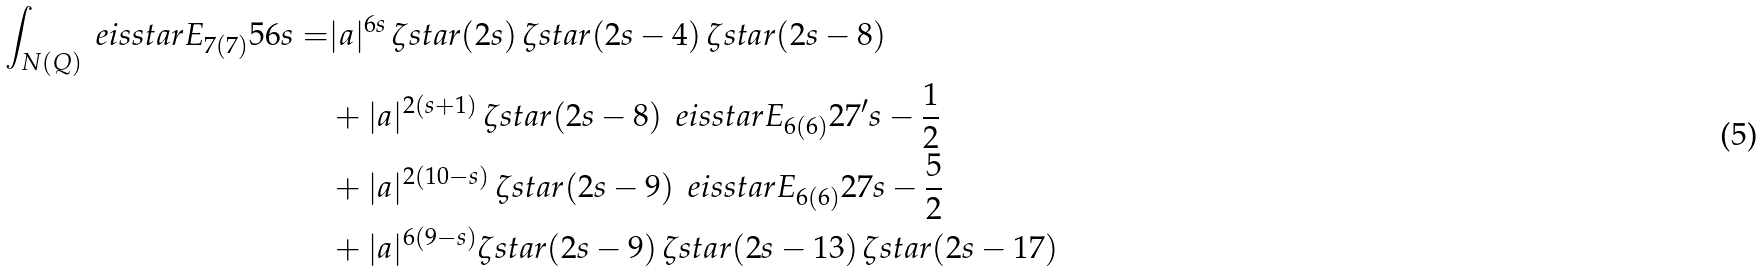<formula> <loc_0><loc_0><loc_500><loc_500>\int _ { N ( Q ) } \ e i s s t a r { E _ { 7 ( 7 ) } } { 5 6 } { s } = & | a | ^ { 6 s } \, \zeta s t a r ( 2 s ) \, \zeta s t a r ( 2 s - 4 ) \, \zeta s t a r ( 2 s - 8 ) \\ & + | a | ^ { 2 ( s + 1 ) } \, \zeta s t a r ( 2 s - 8 ) \, \ e i s s t a r { E _ { 6 ( 6 ) } } { 2 7 ^ { \prime } } { s - \frac { 1 } { 2 } } \\ & + | a | ^ { 2 ( 1 0 - s ) } \, \zeta s t a r ( 2 s - 9 ) \, \ e i s s t a r { E _ { 6 ( 6 ) } } { 2 7 } { s - \frac { 5 } { 2 } } \\ & + | a | ^ { 6 ( 9 - s ) } \zeta s t a r ( 2 s - 9 ) \, \zeta s t a r ( 2 s - 1 3 ) \, \zeta s t a r ( 2 s - 1 7 )</formula> 